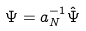Convert formula to latex. <formula><loc_0><loc_0><loc_500><loc_500>\Psi = a _ { N } ^ { - 1 } \hat { \Psi }</formula> 